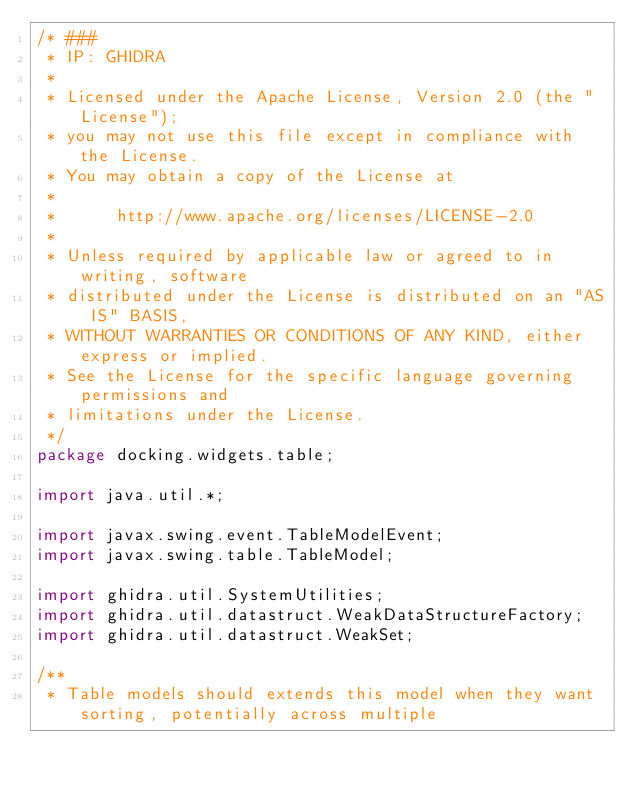<code> <loc_0><loc_0><loc_500><loc_500><_Java_>/* ###
 * IP: GHIDRA
 *
 * Licensed under the Apache License, Version 2.0 (the "License");
 * you may not use this file except in compliance with the License.
 * You may obtain a copy of the License at
 * 
 *      http://www.apache.org/licenses/LICENSE-2.0
 * 
 * Unless required by applicable law or agreed to in writing, software
 * distributed under the License is distributed on an "AS IS" BASIS,
 * WITHOUT WARRANTIES OR CONDITIONS OF ANY KIND, either express or implied.
 * See the License for the specific language governing permissions and
 * limitations under the License.
 */
package docking.widgets.table;

import java.util.*;

import javax.swing.event.TableModelEvent;
import javax.swing.table.TableModel;

import ghidra.util.SystemUtilities;
import ghidra.util.datastruct.WeakDataStructureFactory;
import ghidra.util.datastruct.WeakSet;

/**
 * Table models should extends this model when they want sorting, potentially across multiple</code> 